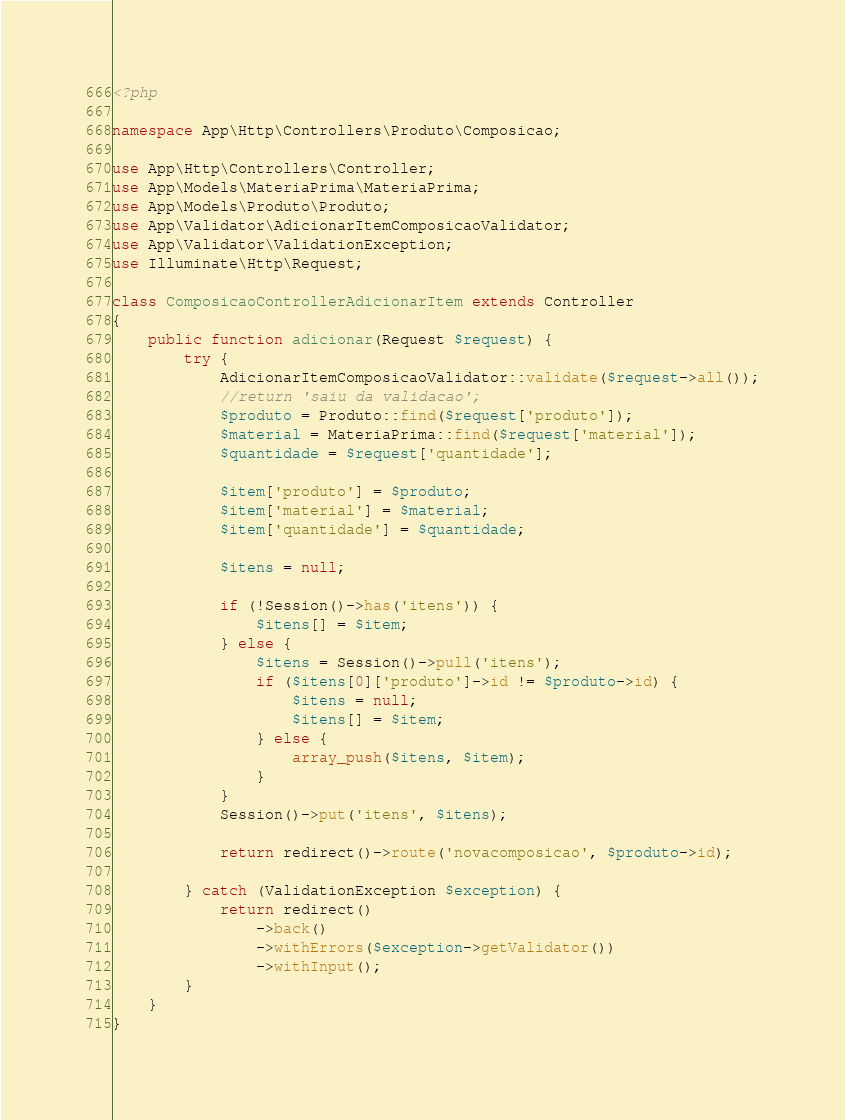<code> <loc_0><loc_0><loc_500><loc_500><_PHP_><?php

namespace App\Http\Controllers\Produto\Composicao;

use App\Http\Controllers\Controller;
use App\Models\MateriaPrima\MateriaPrima;
use App\Models\Produto\Produto;
use App\Validator\AdicionarItemComposicaoValidator;
use App\Validator\ValidationException;
use Illuminate\Http\Request;

class ComposicaoControllerAdicionarItem extends Controller
{
    public function adicionar(Request $request) {
        try {
            AdicionarItemComposicaoValidator::validate($request->all());
            //return 'saiu da validacao';
            $produto = Produto::find($request['produto']);
            $material = MateriaPrima::find($request['material']);
            $quantidade = $request['quantidade'];

            $item['produto'] = $produto;
            $item['material'] = $material;
            $item['quantidade'] = $quantidade;

            $itens = null;

            if (!Session()->has('itens')) {
                $itens[] = $item;
            } else {
                $itens = Session()->pull('itens');
                if ($itens[0]['produto']->id != $produto->id) {
                    $itens = null;
                    $itens[] = $item;
                } else {
                    array_push($itens, $item);
                }
            }
            Session()->put('itens', $itens);

            return redirect()->route('novacomposicao', $produto->id);

        } catch (ValidationException $exception) {
            return redirect()
                ->back()
                ->withErrors($exception->getValidator())
                ->withInput();
        }
    }
}
</code> 